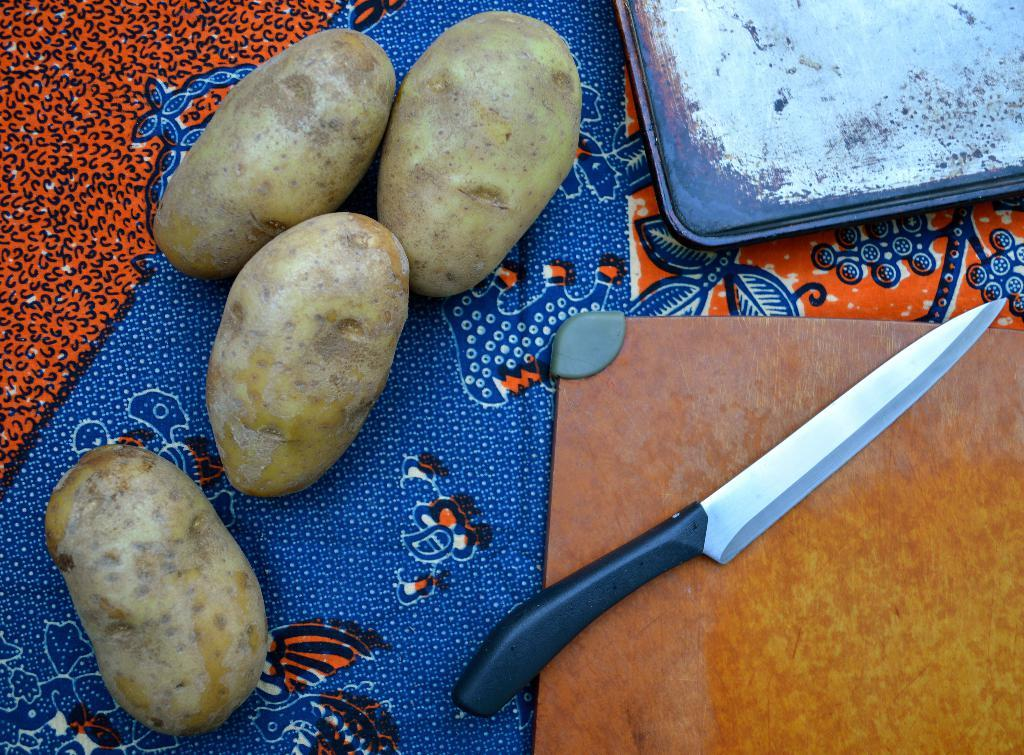What type of food is present in the image? There are potatoes in the image. What utensil can be seen in the image? There is a knife in the image. What is the potatoes placed on in the image? There are boards on a cloth in the image. How many goldfish are swimming in the image? There are no goldfish present in the image. What type of plastic material is visible in the image? There is no plastic material visible in the image. 